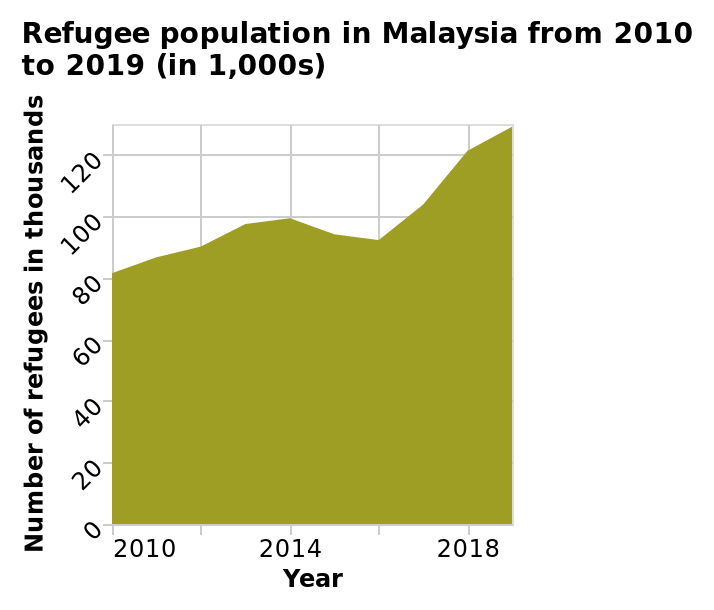<image>
What has happened to the refugee population in Malaysia in recent years? The refugee population in Malaysia has experienced a significant increase in the past few years. Can you discuss the changes in the refugee population in Malaysia since 2016? Since 2016, the refugee population in Malaysia has witnessed a significant rise. 